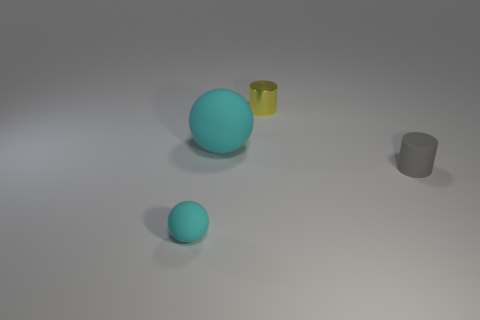Add 3 large balls. How many objects exist? 7 Add 1 tiny blue balls. How many tiny blue balls exist? 1 Subtract 0 purple spheres. How many objects are left? 4 Subtract all big cyan rubber cylinders. Subtract all cylinders. How many objects are left? 2 Add 4 balls. How many balls are left? 6 